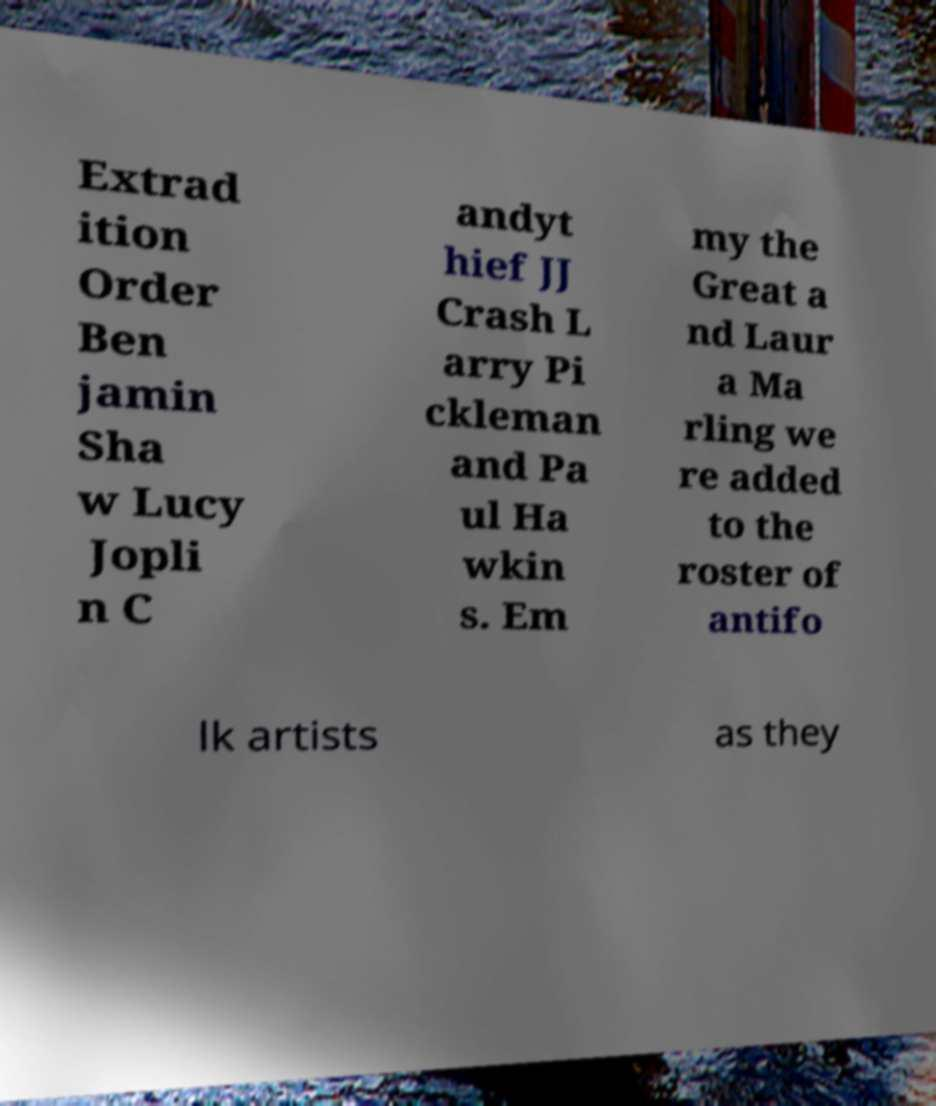There's text embedded in this image that I need extracted. Can you transcribe it verbatim? Extrad ition Order Ben jamin Sha w Lucy Jopli n C andyt hief JJ Crash L arry Pi ckleman and Pa ul Ha wkin s. Em my the Great a nd Laur a Ma rling we re added to the roster of antifo lk artists as they 